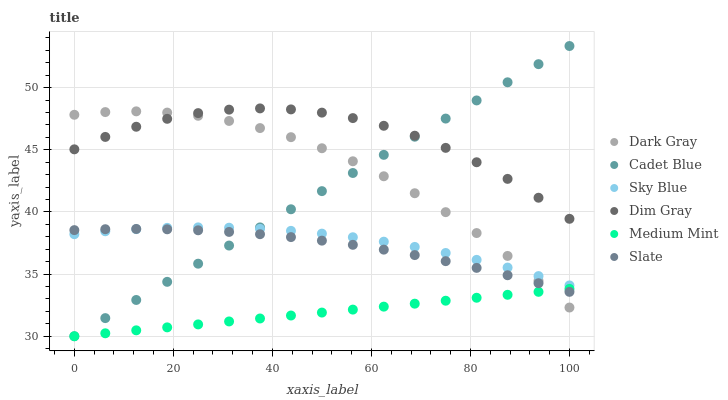Does Medium Mint have the minimum area under the curve?
Answer yes or no. Yes. Does Dim Gray have the maximum area under the curve?
Answer yes or no. Yes. Does Slate have the minimum area under the curve?
Answer yes or no. No. Does Slate have the maximum area under the curve?
Answer yes or no. No. Is Medium Mint the smoothest?
Answer yes or no. Yes. Is Dim Gray the roughest?
Answer yes or no. Yes. Is Slate the smoothest?
Answer yes or no. No. Is Slate the roughest?
Answer yes or no. No. Does Medium Mint have the lowest value?
Answer yes or no. Yes. Does Slate have the lowest value?
Answer yes or no. No. Does Cadet Blue have the highest value?
Answer yes or no. Yes. Does Dim Gray have the highest value?
Answer yes or no. No. Is Sky Blue less than Dim Gray?
Answer yes or no. Yes. Is Dim Gray greater than Sky Blue?
Answer yes or no. Yes. Does Cadet Blue intersect Dark Gray?
Answer yes or no. Yes. Is Cadet Blue less than Dark Gray?
Answer yes or no. No. Is Cadet Blue greater than Dark Gray?
Answer yes or no. No. Does Sky Blue intersect Dim Gray?
Answer yes or no. No. 